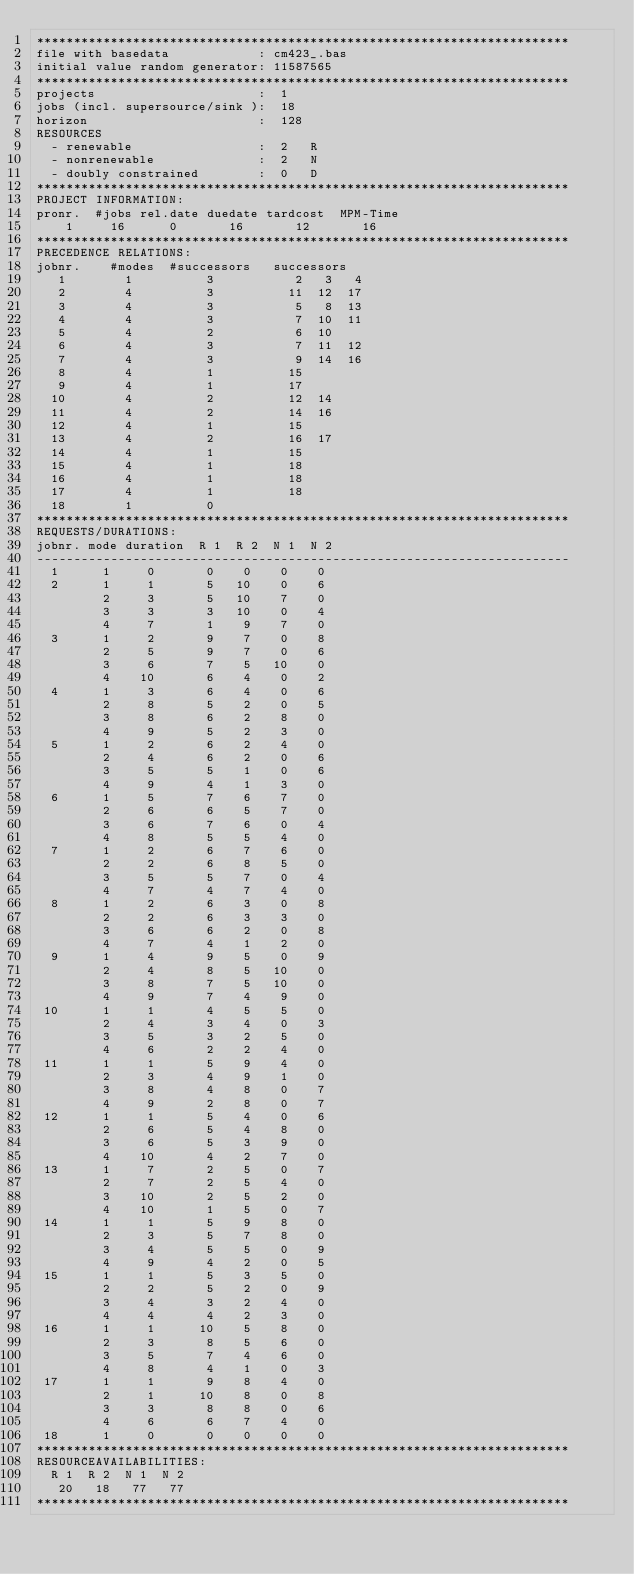<code> <loc_0><loc_0><loc_500><loc_500><_ObjectiveC_>************************************************************************
file with basedata            : cm423_.bas
initial value random generator: 11587565
************************************************************************
projects                      :  1
jobs (incl. supersource/sink ):  18
horizon                       :  128
RESOURCES
  - renewable                 :  2   R
  - nonrenewable              :  2   N
  - doubly constrained        :  0   D
************************************************************************
PROJECT INFORMATION:
pronr.  #jobs rel.date duedate tardcost  MPM-Time
    1     16      0       16       12       16
************************************************************************
PRECEDENCE RELATIONS:
jobnr.    #modes  #successors   successors
   1        1          3           2   3   4
   2        4          3          11  12  17
   3        4          3           5   8  13
   4        4          3           7  10  11
   5        4          2           6  10
   6        4          3           7  11  12
   7        4          3           9  14  16
   8        4          1          15
   9        4          1          17
  10        4          2          12  14
  11        4          2          14  16
  12        4          1          15
  13        4          2          16  17
  14        4          1          15
  15        4          1          18
  16        4          1          18
  17        4          1          18
  18        1          0        
************************************************************************
REQUESTS/DURATIONS:
jobnr. mode duration  R 1  R 2  N 1  N 2
------------------------------------------------------------------------
  1      1     0       0    0    0    0
  2      1     1       5   10    0    6
         2     3       5   10    7    0
         3     3       3   10    0    4
         4     7       1    9    7    0
  3      1     2       9    7    0    8
         2     5       9    7    0    6
         3     6       7    5   10    0
         4    10       6    4    0    2
  4      1     3       6    4    0    6
         2     8       5    2    0    5
         3     8       6    2    8    0
         4     9       5    2    3    0
  5      1     2       6    2    4    0
         2     4       6    2    0    6
         3     5       5    1    0    6
         4     9       4    1    3    0
  6      1     5       7    6    7    0
         2     6       6    5    7    0
         3     6       7    6    0    4
         4     8       5    5    4    0
  7      1     2       6    7    6    0
         2     2       6    8    5    0
         3     5       5    7    0    4
         4     7       4    7    4    0
  8      1     2       6    3    0    8
         2     2       6    3    3    0
         3     6       6    2    0    8
         4     7       4    1    2    0
  9      1     4       9    5    0    9
         2     4       8    5   10    0
         3     8       7    5   10    0
         4     9       7    4    9    0
 10      1     1       4    5    5    0
         2     4       3    4    0    3
         3     5       3    2    5    0
         4     6       2    2    4    0
 11      1     1       5    9    4    0
         2     3       4    9    1    0
         3     8       4    8    0    7
         4     9       2    8    0    7
 12      1     1       5    4    0    6
         2     6       5    4    8    0
         3     6       5    3    9    0
         4    10       4    2    7    0
 13      1     7       2    5    0    7
         2     7       2    5    4    0
         3    10       2    5    2    0
         4    10       1    5    0    7
 14      1     1       5    9    8    0
         2     3       5    7    8    0
         3     4       5    5    0    9
         4     9       4    2    0    5
 15      1     1       5    3    5    0
         2     2       5    2    0    9
         3     4       3    2    4    0
         4     4       4    2    3    0
 16      1     1      10    5    8    0
         2     3       8    5    6    0
         3     5       7    4    6    0
         4     8       4    1    0    3
 17      1     1       9    8    4    0
         2     1      10    8    0    8
         3     3       8    8    0    6
         4     6       6    7    4    0
 18      1     0       0    0    0    0
************************************************************************
RESOURCEAVAILABILITIES:
  R 1  R 2  N 1  N 2
   20   18   77   77
************************************************************************
</code> 